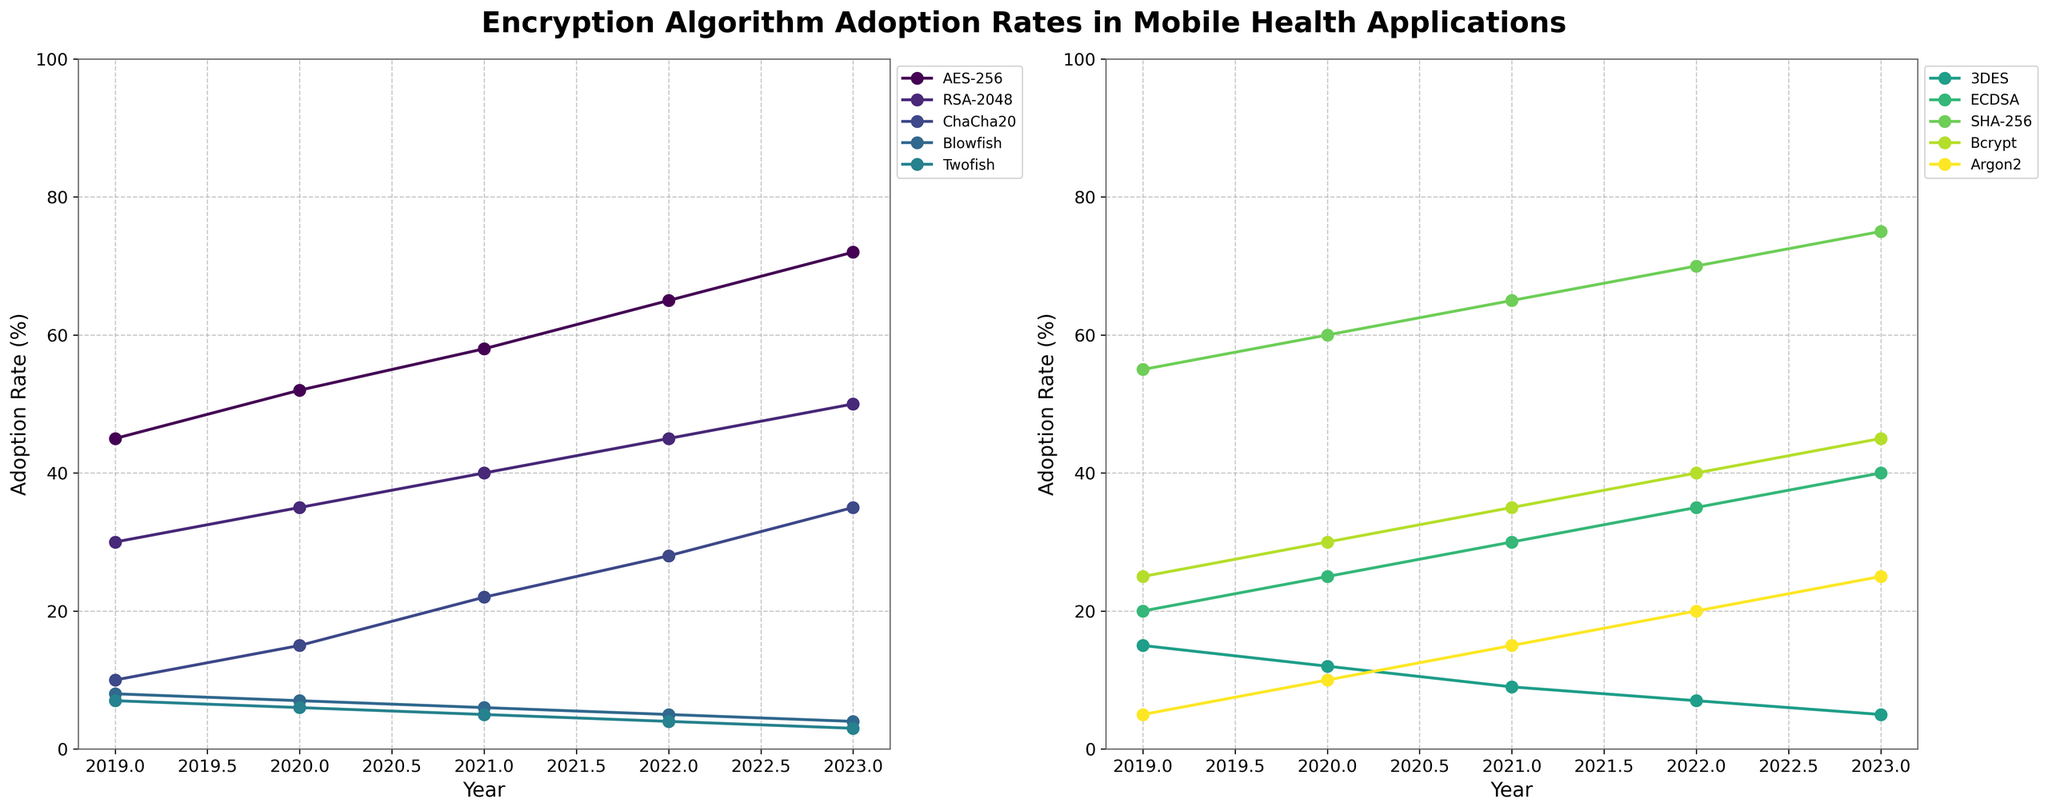Which algorithm shows the highest adoption rate in 2023? To identify the algorithm with the highest adoption rate in 2023, look at the values for each algorithm in the year 2023. According to the data, SHA-256 has the highest adoption rate at 75%.
Answer: SHA-256 Which algorithms had a decline in adoption rates over the years? To determine which algorithms had a decline in adoption rates, observe the trend lines in the plots for each algorithm. Blowfish, Twofish, and 3DES all show a downward trend from 2019 to 2023.
Answer: Blowfish, Twofish, 3DES By how many percentage points did AES-256’s adoption rate increase from 2019 to 2023? To find the increase in percentage points, subtract the adoption rate in 2019 from the adoption rate in 2023 for AES-256. This calculation is 72% - 45% = 27%.
Answer: 27% Which algorithm had the smallest increase in adoption rate from 2019 to 2023? Compare the adoption rate differences from 2019 to 2023 for each algorithm and find the smallest increase. Blowfish had a decrease, but among those with an increase, RSA-2048 had a 20% increase, the smallest among the algorithms showing an increase.
Answer: RSA-2048 Compare the adoption rate of ECDSA in 2020 and Argon2 in 2023. Which was higher? Read the values directly from the figure: ECDSA in 2020 was at 25%, and Argon2 in 2023 was at 25%. Both have the same rate.
Answer: Equal Which algorithms consistently show a year-on-year increase in adoption rate? Check the trend lines for each algorithm and confirm those with consistent upward trends. AES-256, RSA-2048, ChaCha20, ECDSA, SHA-256, Bcrypt, and Argon2 all show a consistent year-on-year increase in adoption rates.
Answer: AES-256, RSA-2048, ChaCha20, ECDSA, SHA-256, Bcrypt, Argon2 What is the average adoption rate of AES-256 over the five years? Calculate the average by summing the adoption rates of AES-256 from 2019 to 2023 and then dividing by the number of years. The calculation is (45 + 52 + 58 + 65 + 72) / 5 = 58.4%.
Answer: 58.4% Which algorithm has the steepest increase in adoption rate from 2020 to 2021? To determine the steepest increase, look at the slopes of the trend lines between 2020 and 2021. Argon2 shows the highest increase from 10% in 2020 to 15% in 2021.
Answer: Argon2 What was the adoption rate of 3DES in 2021 and how does it compare to its adoption rate in 2019? Find the values for 3DES in 2021 and 2019 from the figure; 3DES had 9% adoption in 2021 and 15% in 2019. This shows a decrease over the period.
Answer: 9%, decreased from 2019 Is the adoption rate of Bcrypt higher than that of ChaCha20 in 2022? Compare the adoption rates of Bcrypt and ChaCha20 for the year 2022. Bcrypt is at 40% while ChaCha20 is at 28%. Bcrypt is higher.
Answer: Higher 